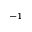<formula> <loc_0><loc_0><loc_500><loc_500>^ { - 1 }</formula> 